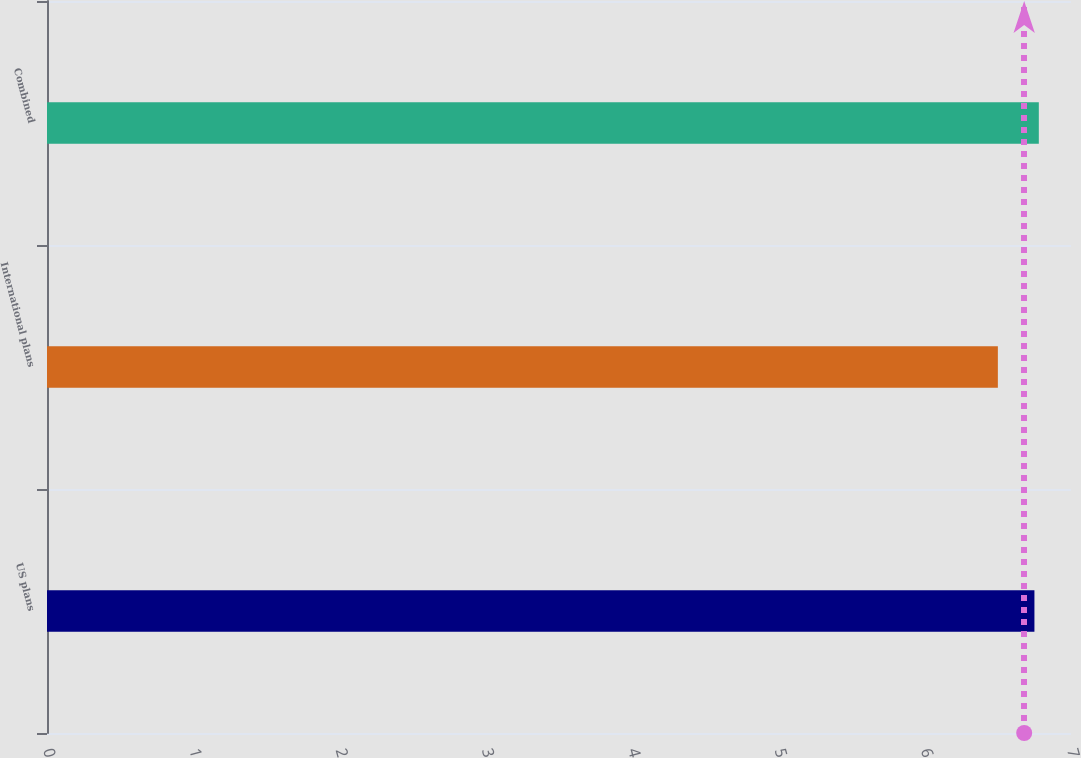<chart> <loc_0><loc_0><loc_500><loc_500><bar_chart><fcel>US plans<fcel>International plans<fcel>Combined<nl><fcel>6.75<fcel>6.5<fcel>6.78<nl></chart> 